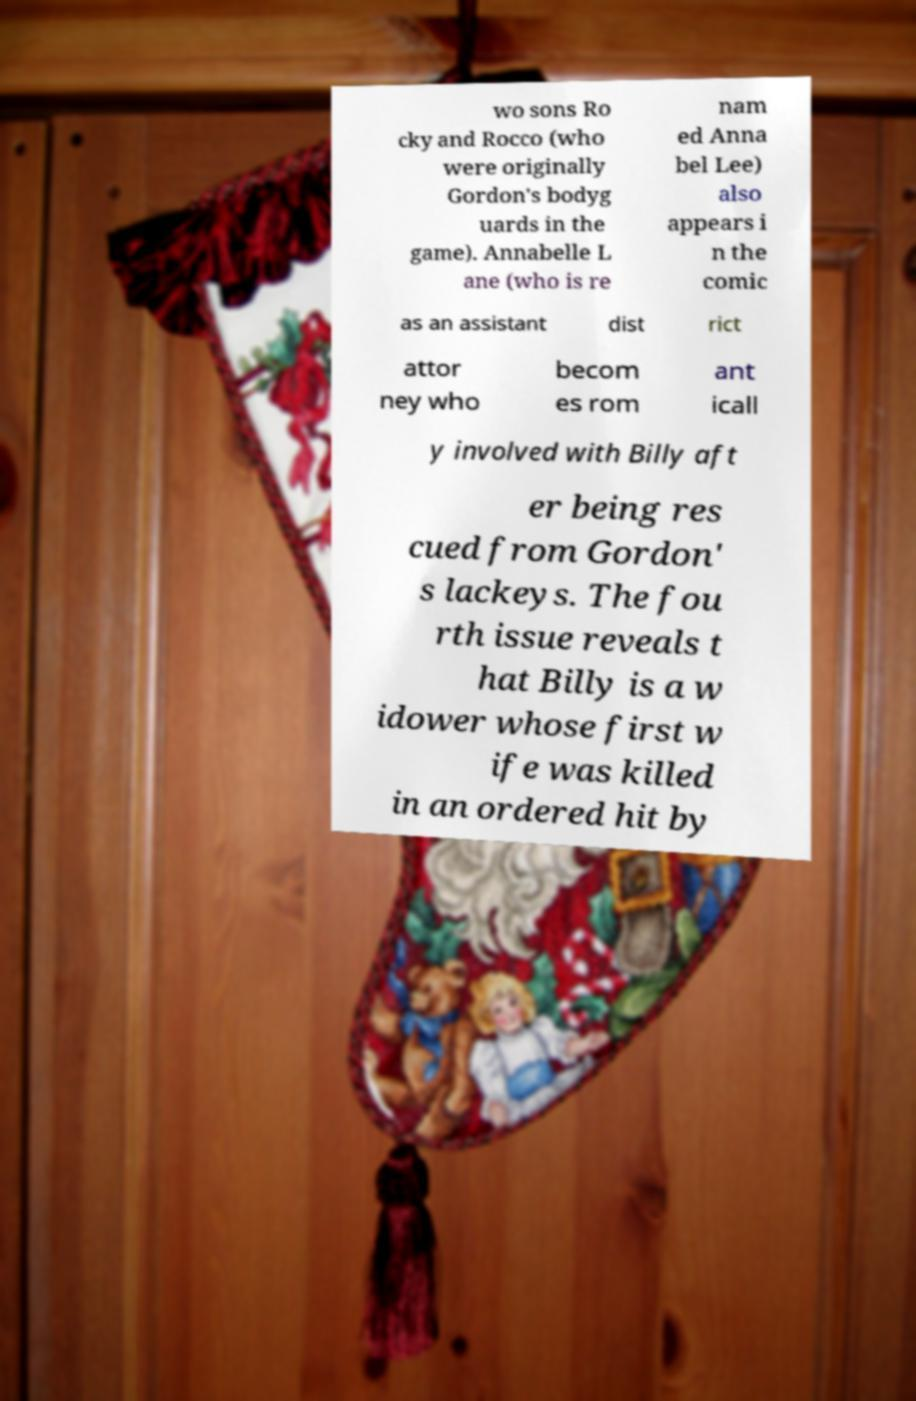What messages or text are displayed in this image? I need them in a readable, typed format. wo sons Ro cky and Rocco (who were originally Gordon's bodyg uards in the game). Annabelle L ane (who is re nam ed Anna bel Lee) also appears i n the comic as an assistant dist rict attor ney who becom es rom ant icall y involved with Billy aft er being res cued from Gordon' s lackeys. The fou rth issue reveals t hat Billy is a w idower whose first w ife was killed in an ordered hit by 